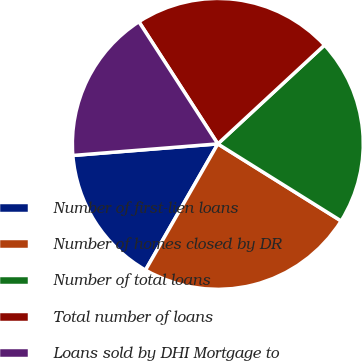Convert chart. <chart><loc_0><loc_0><loc_500><loc_500><pie_chart><fcel>Number of first-lien loans<fcel>Number of homes closed by DR<fcel>Number of total loans<fcel>Total number of loans<fcel>Loans sold by DHI Mortgage to<nl><fcel>15.45%<fcel>24.39%<fcel>20.78%<fcel>22.24%<fcel>17.14%<nl></chart> 